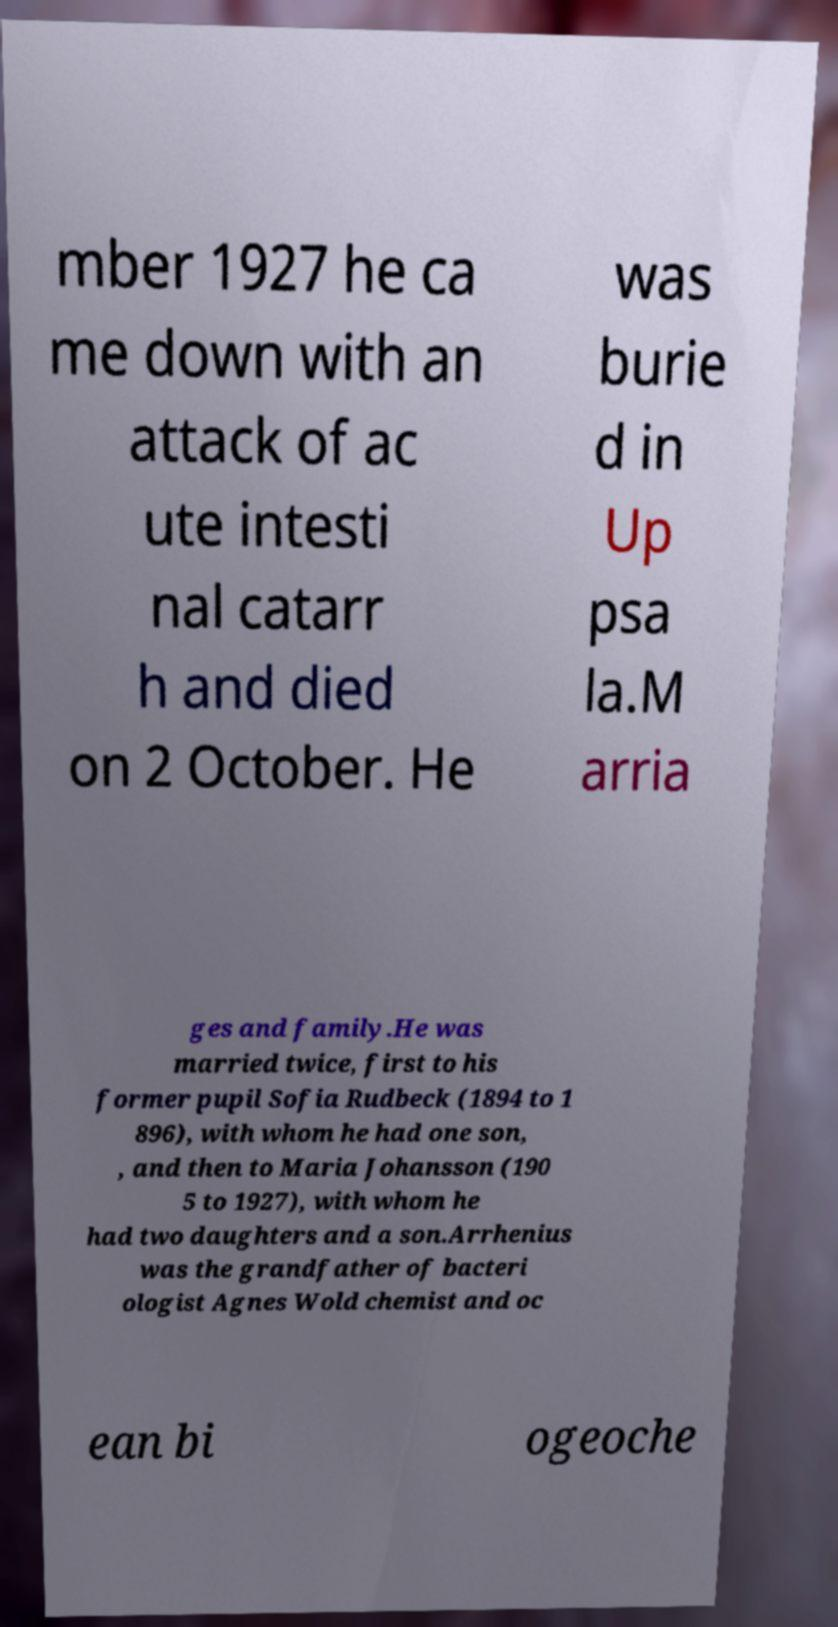I need the written content from this picture converted into text. Can you do that? mber 1927 he ca me down with an attack of ac ute intesti nal catarr h and died on 2 October. He was burie d in Up psa la.M arria ges and family.He was married twice, first to his former pupil Sofia Rudbeck (1894 to 1 896), with whom he had one son, , and then to Maria Johansson (190 5 to 1927), with whom he had two daughters and a son.Arrhenius was the grandfather of bacteri ologist Agnes Wold chemist and oc ean bi ogeoche 